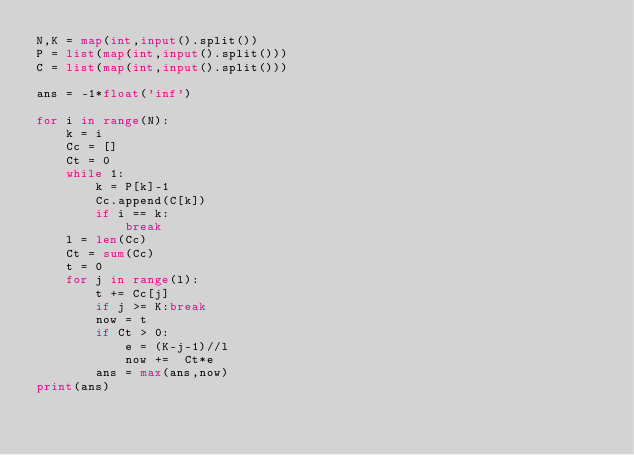<code> <loc_0><loc_0><loc_500><loc_500><_Python_>N,K = map(int,input().split())
P = list(map(int,input().split()))
C = list(map(int,input().split()))

ans = -1*float('inf')

for i in range(N):
    k = i
    Cc = []
    Ct = 0
    while 1:
        k = P[k]-1
        Cc.append(C[k])
        if i == k:
            break
    l = len(Cc)
    Ct = sum(Cc)
    t = 0
    for j in range(l):
        t += Cc[j]
        if j >= K:break
        now = t
        if Ct > 0:
            e = (K-j-1)//l
            now +=  Ct*e
        ans = max(ans,now)
print(ans)</code> 